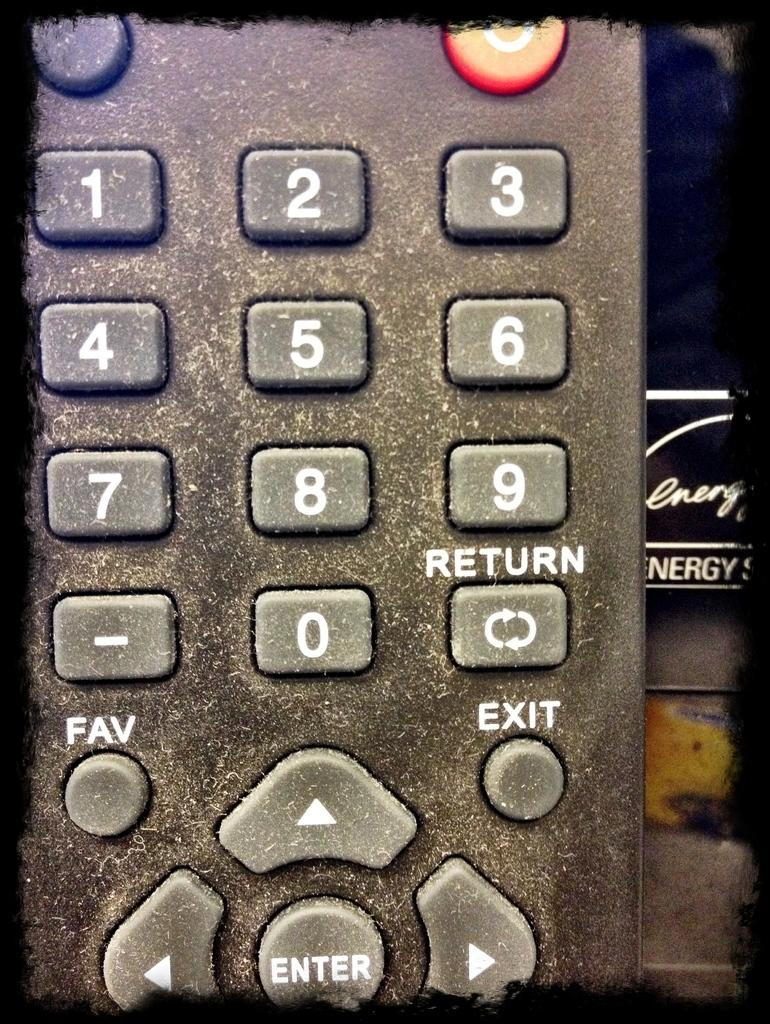<image>
Write a terse but informative summary of the picture. a close up of a dirty remote with Fav and Exit buttons 